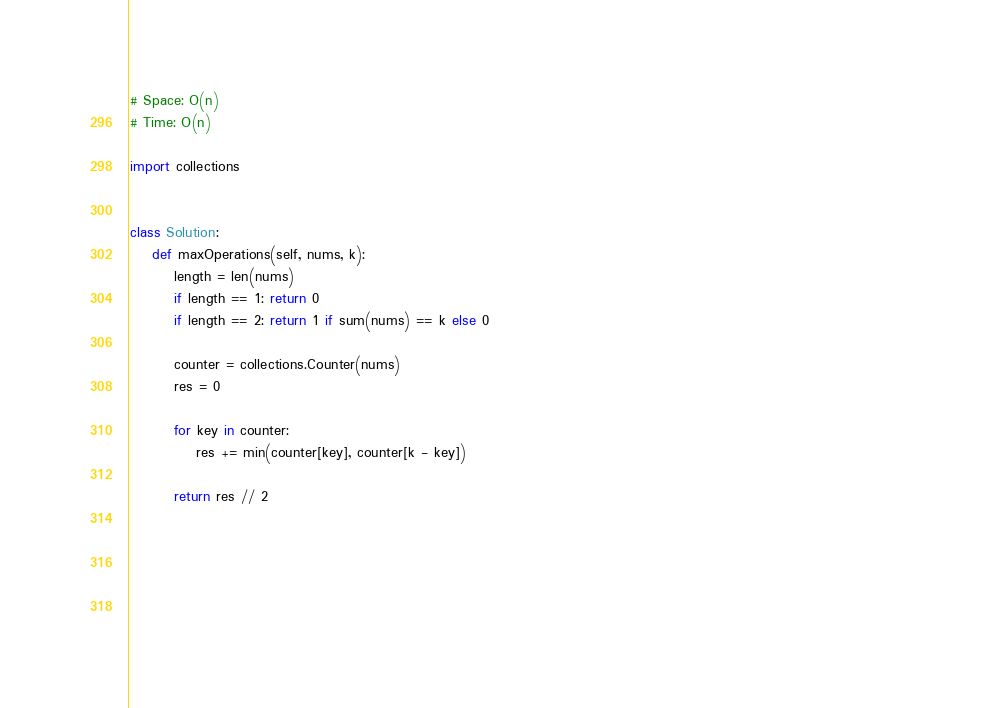<code> <loc_0><loc_0><loc_500><loc_500><_Python_>
# Space: O(n)
# Time: O(n)

import collections


class Solution:
    def maxOperations(self, nums, k):
        length = len(nums)
        if length == 1: return 0
        if length == 2: return 1 if sum(nums) == k else 0

        counter = collections.Counter(nums)
        res = 0

        for key in counter:
            res += min(counter[key], counter[k - key])

        return res // 2




                                                                                                                                           </code> 